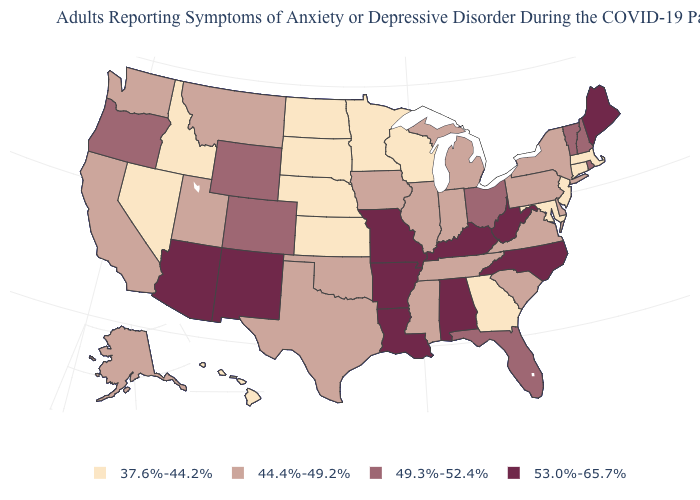Does the first symbol in the legend represent the smallest category?
Short answer required. Yes. Does Vermont have the same value as Ohio?
Write a very short answer. Yes. How many symbols are there in the legend?
Write a very short answer. 4. Does the first symbol in the legend represent the smallest category?
Concise answer only. Yes. Does Michigan have the same value as Wyoming?
Concise answer only. No. Which states have the lowest value in the West?
Answer briefly. Hawaii, Idaho, Nevada. Name the states that have a value in the range 44.4%-49.2%?
Short answer required. Alaska, California, Delaware, Illinois, Indiana, Iowa, Michigan, Mississippi, Montana, New York, Oklahoma, Pennsylvania, South Carolina, Tennessee, Texas, Utah, Virginia, Washington. Does the map have missing data?
Short answer required. No. Does the map have missing data?
Keep it brief. No. Which states hav the highest value in the South?
Quick response, please. Alabama, Arkansas, Kentucky, Louisiana, North Carolina, West Virginia. What is the value of Alaska?
Concise answer only. 44.4%-49.2%. Name the states that have a value in the range 44.4%-49.2%?
Quick response, please. Alaska, California, Delaware, Illinois, Indiana, Iowa, Michigan, Mississippi, Montana, New York, Oklahoma, Pennsylvania, South Carolina, Tennessee, Texas, Utah, Virginia, Washington. What is the lowest value in the USA?
Keep it brief. 37.6%-44.2%. Does Maine have a higher value than Utah?
Short answer required. Yes. 